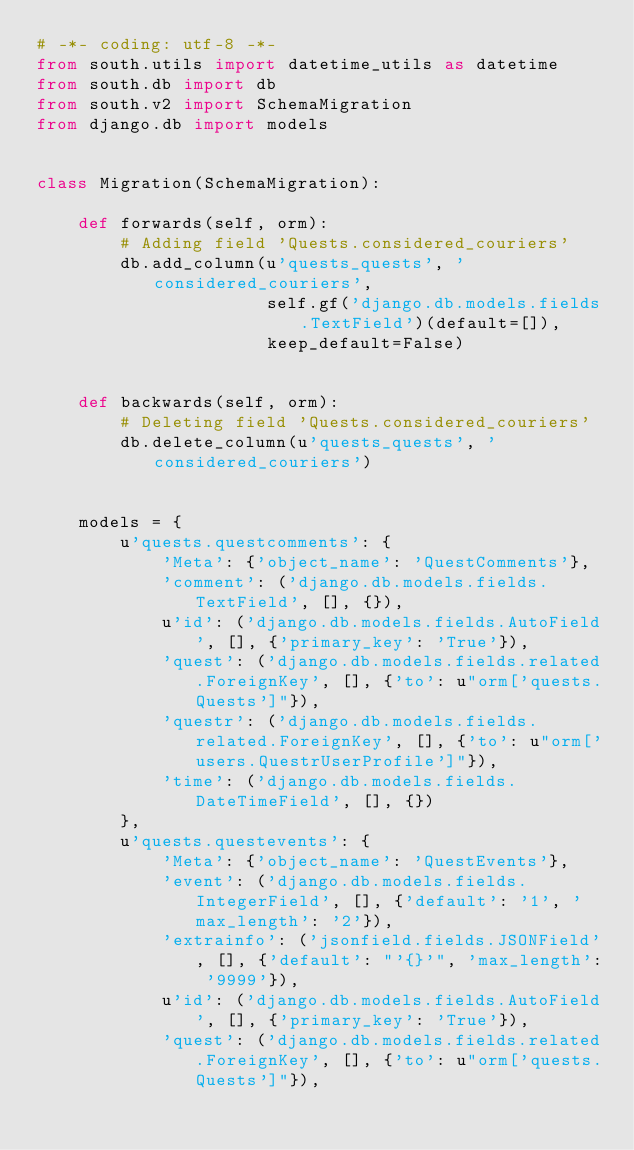Convert code to text. <code><loc_0><loc_0><loc_500><loc_500><_Python_># -*- coding: utf-8 -*-
from south.utils import datetime_utils as datetime
from south.db import db
from south.v2 import SchemaMigration
from django.db import models


class Migration(SchemaMigration):

    def forwards(self, orm):
        # Adding field 'Quests.considered_couriers'
        db.add_column(u'quests_quests', 'considered_couriers',
                      self.gf('django.db.models.fields.TextField')(default=[]),
                      keep_default=False)


    def backwards(self, orm):
        # Deleting field 'Quests.considered_couriers'
        db.delete_column(u'quests_quests', 'considered_couriers')


    models = {
        u'quests.questcomments': {
            'Meta': {'object_name': 'QuestComments'},
            'comment': ('django.db.models.fields.TextField', [], {}),
            u'id': ('django.db.models.fields.AutoField', [], {'primary_key': 'True'}),
            'quest': ('django.db.models.fields.related.ForeignKey', [], {'to': u"orm['quests.Quests']"}),
            'questr': ('django.db.models.fields.related.ForeignKey', [], {'to': u"orm['users.QuestrUserProfile']"}),
            'time': ('django.db.models.fields.DateTimeField', [], {})
        },
        u'quests.questevents': {
            'Meta': {'object_name': 'QuestEvents'},
            'event': ('django.db.models.fields.IntegerField', [], {'default': '1', 'max_length': '2'}),
            'extrainfo': ('jsonfield.fields.JSONField', [], {'default': "'{}'", 'max_length': '9999'}),
            u'id': ('django.db.models.fields.AutoField', [], {'primary_key': 'True'}),
            'quest': ('django.db.models.fields.related.ForeignKey', [], {'to': u"orm['quests.Quests']"}),</code> 